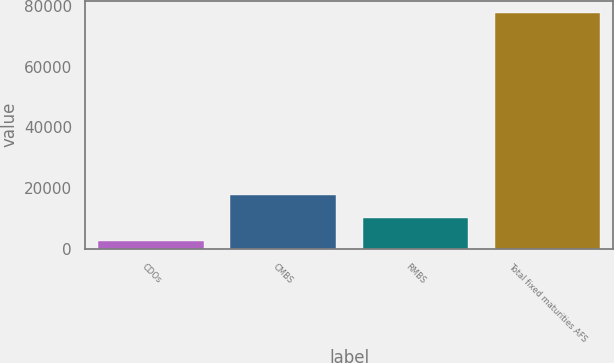<chart> <loc_0><loc_0><loc_500><loc_500><bar_chart><fcel>CDOs<fcel>CMBS<fcel>RMBS<fcel>Total fixed maturities AFS<nl><fcel>2611<fcel>17652.8<fcel>10131.9<fcel>77820<nl></chart> 